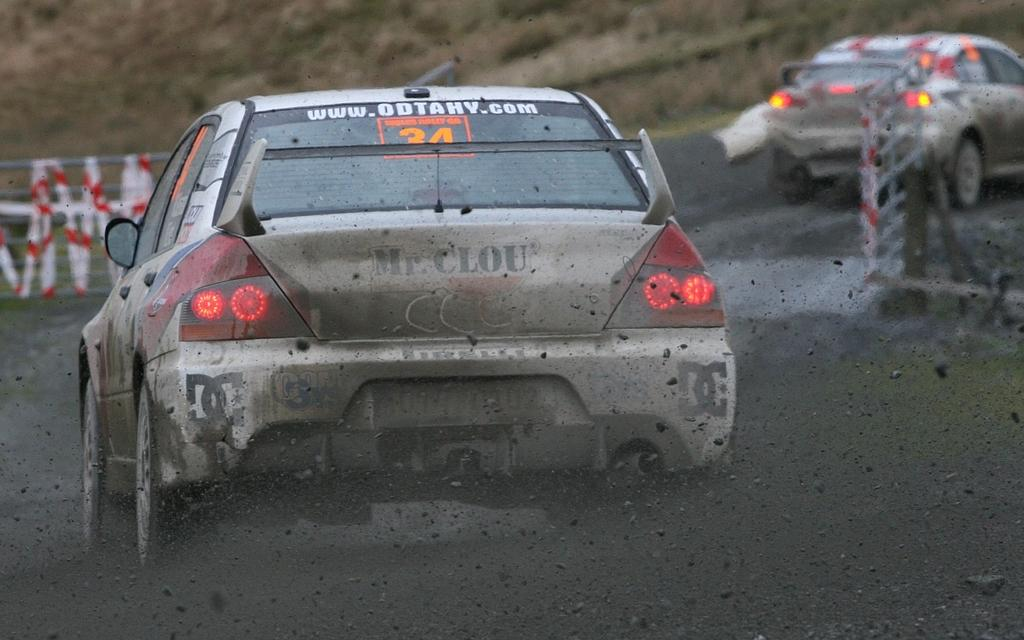What is happening in the image involving a car? There is a car moving in the image. Can you describe the other car in the image? There is another car on the right side of the image. What type of surface is visible on the floor in the image? There is black soil on the floor in the image. What can be seen in the distance in the image? There is a mountain in the background of the image. What is the rate at which the giants are walking in the image? There are no giants present in the image, so there is no rate at which they could be walking. 